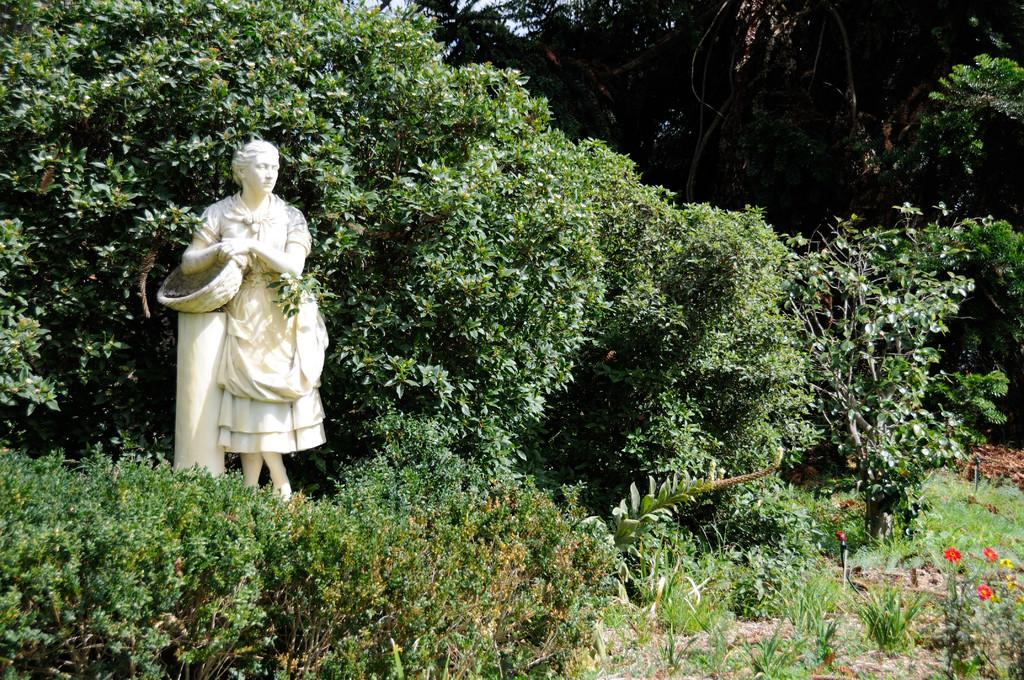What is located at the bottom of the image? There are many plants at the bottom of the image. What can be seen on the left side of the image? There is a statue of a person on the left side of the image. What is visible in the background of the image? There are many trees in the background of the image. What type of hole can be seen in the image? There is no hole present in the image. What kind of trouble is the statue facing in the image? The statue is not facing any trouble in the image; it is a stationary object. 